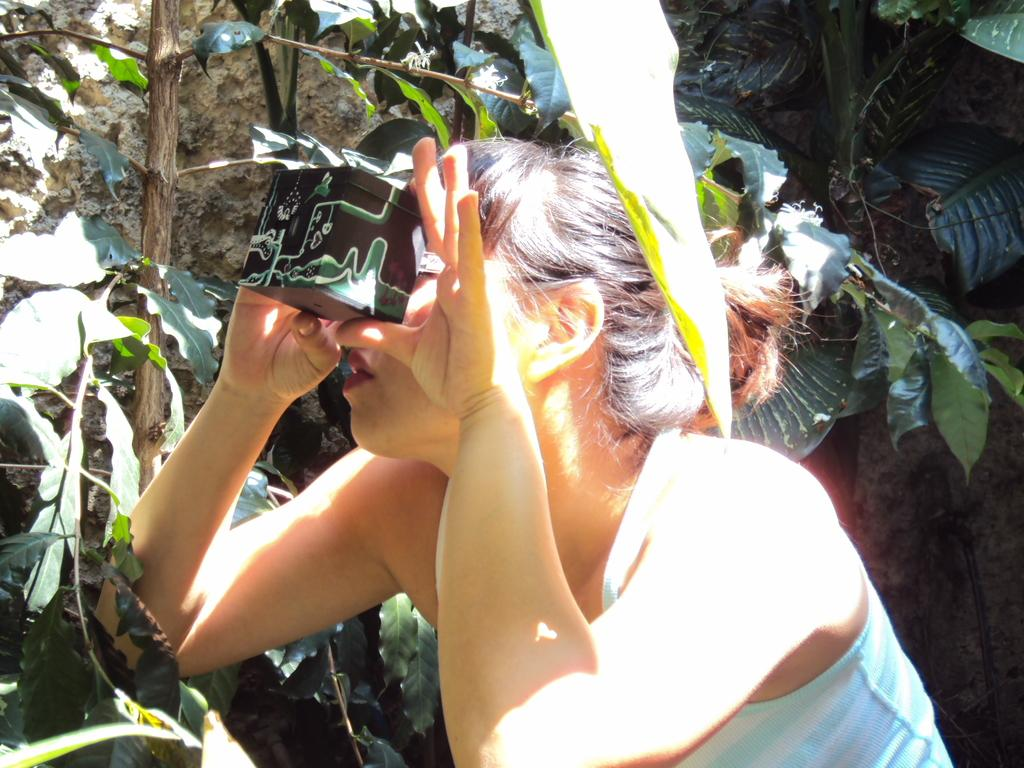Who is present in the image? There is a woman in the image. What is the woman holding in the image? The woman is holding a box. What can be seen in the background of the image? There are rocks and trees in the background of the image. What type of icicle can be seen hanging from the woman's hair in the image? There is no icicle present in the image, and the woman's hair does not have any icicles hanging from it. 